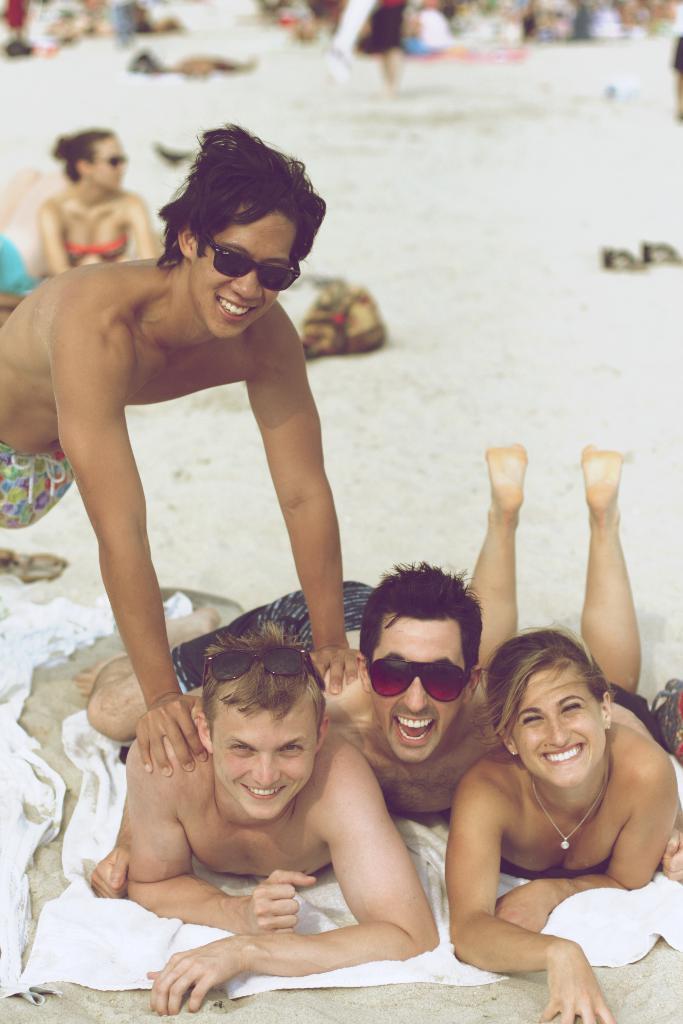What are the people lying on in the image? The people are lying on a cloth on the land. Can you describe the person wearing goggles? Yes, there is a person wearing goggles in the image. How many people are on the land in the image? There are people on the land in the image. What else can be seen on the land besides the people? There are objects on the land in the image. What is the result of adding 2 and 3 in the image? There is no addition or mathematical operation being performed in the image; it features people lying on a cloth and a person wearing goggles. Can you describe the rock formation in the image? There is no rock formation present in the image. 